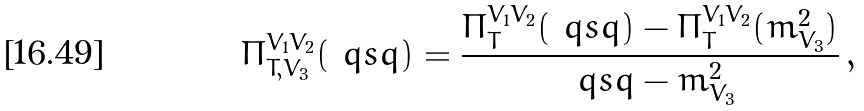<formula> <loc_0><loc_0><loc_500><loc_500>\Pi ^ { V _ { 1 } V _ { 2 } } _ { T , V _ { 3 } } ( \ q s q ) = \frac { \Pi ^ { V _ { 1 } V _ { 2 } } _ { T } ( \ q s q ) - \Pi ^ { V _ { 1 } V _ { 2 } } _ { T } ( m ^ { 2 } _ { V _ { 3 } } ) } { \ q s q - m ^ { 2 } _ { V _ { 3 } } } \, ,</formula> 